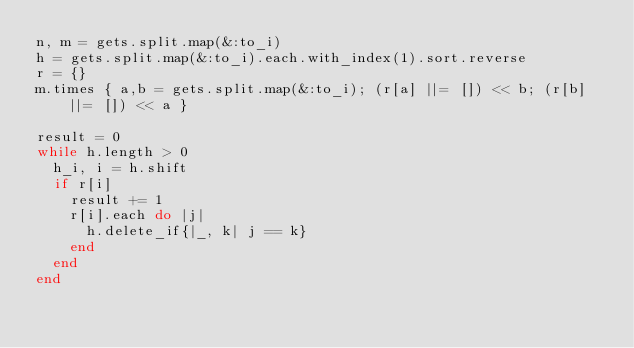<code> <loc_0><loc_0><loc_500><loc_500><_Ruby_>n, m = gets.split.map(&:to_i)
h = gets.split.map(&:to_i).each.with_index(1).sort.reverse
r = {}
m.times { a,b = gets.split.map(&:to_i); (r[a] ||= []) << b; (r[b] ||= []) << a }

result = 0
while h.length > 0
  h_i, i = h.shift
  if r[i]
    result += 1
    r[i].each do |j|
      h.delete_if{|_, k| j == k}
    end
  end
end
</code> 